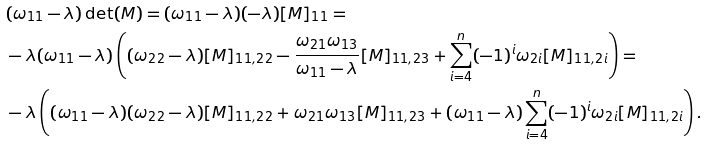Convert formula to latex. <formula><loc_0><loc_0><loc_500><loc_500>& ( \omega _ { 1 1 } - \lambda ) \det ( M ) = ( \omega _ { 1 1 } - \lambda ) ( - \lambda ) [ M ] _ { 1 1 } = \\ & - \lambda ( \omega _ { 1 1 } - \lambda ) \left ( ( \omega _ { 2 2 } - \lambda ) [ M ] _ { 1 1 , 2 2 } - \frac { \omega _ { 2 1 } \omega _ { 1 3 } } { \omega _ { 1 1 } - \lambda } [ M ] _ { 1 1 , 2 3 } + \sum _ { i = 4 } ^ { n } ( - 1 ) ^ { i } \omega _ { 2 i } [ M ] _ { 1 1 , 2 i } \right ) = \\ & - \lambda \left ( ( \omega _ { 1 1 } - \lambda ) ( \omega _ { 2 2 } - \lambda ) [ M ] _ { 1 1 , 2 2 } + \omega _ { 2 1 } \omega _ { 1 3 } [ M ] _ { 1 1 , 2 3 } + ( \omega _ { 1 1 } - \lambda ) \sum _ { i = 4 } ^ { n } ( - 1 ) ^ { i } \omega _ { 2 i } [ M ] _ { 1 1 , 2 i } \right ) .</formula> 